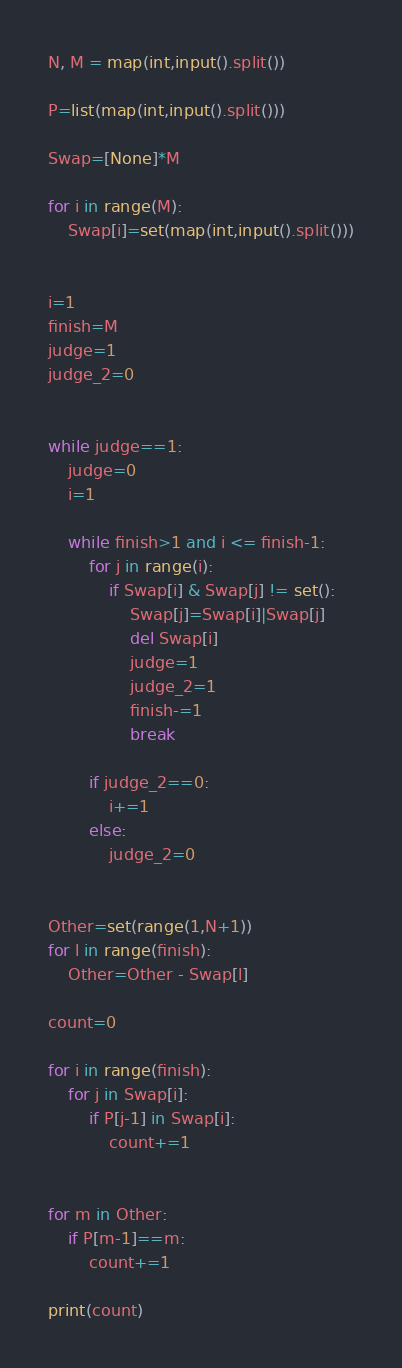Convert code to text. <code><loc_0><loc_0><loc_500><loc_500><_Python_>N, M = map(int,input().split())

P=list(map(int,input().split()))

Swap=[None]*M

for i in range(M):
    Swap[i]=set(map(int,input().split()))


i=1
finish=M
judge=1
judge_2=0


while judge==1:
    judge=0
    i=1

    while finish>1 and i <= finish-1:
        for j in range(i):
            if Swap[i] & Swap[j] != set():
                Swap[j]=Swap[i]|Swap[j]
                del Swap[i]
                judge=1
                judge_2=1
                finish-=1
                break

        if judge_2==0:
            i+=1
        else:
            judge_2=0


Other=set(range(1,N+1))
for l in range(finish):
    Other=Other - Swap[l]

count=0

for i in range(finish):
    for j in Swap[i]:
        if P[j-1] in Swap[i]:
            count+=1
        

for m in Other:
    if P[m-1]==m:
        count+=1

print(count)
</code> 